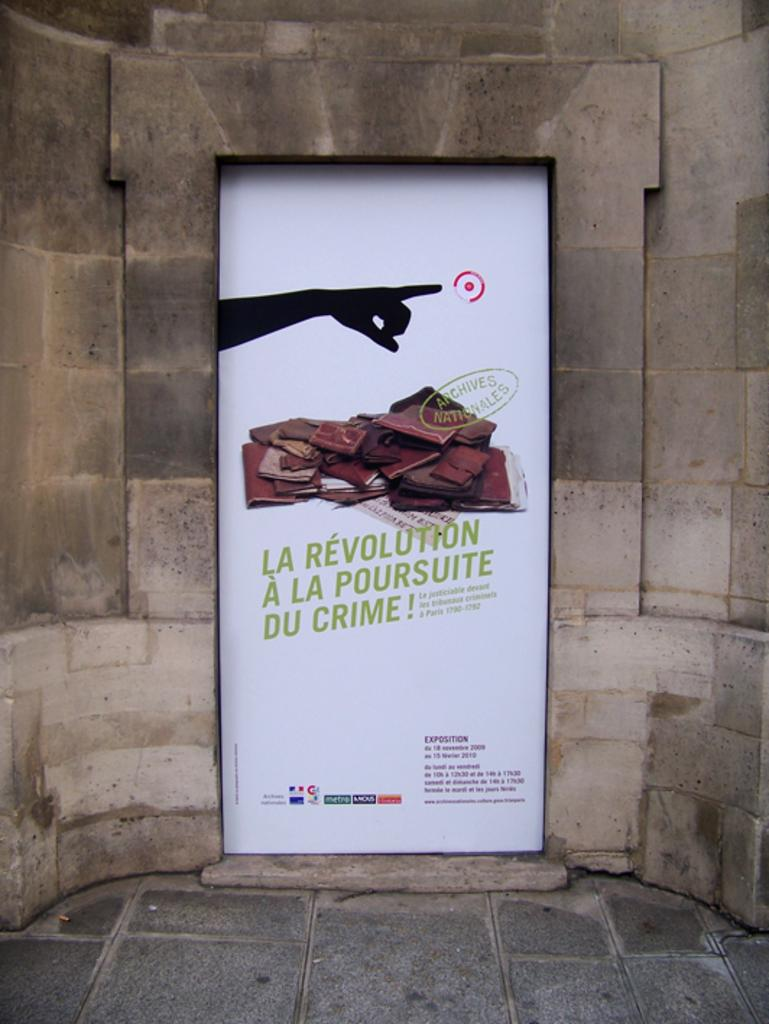<image>
Provide a brief description of the given image. Poster with a finger pointing and the words "La Revolution A La Poursuite Du Crime". 